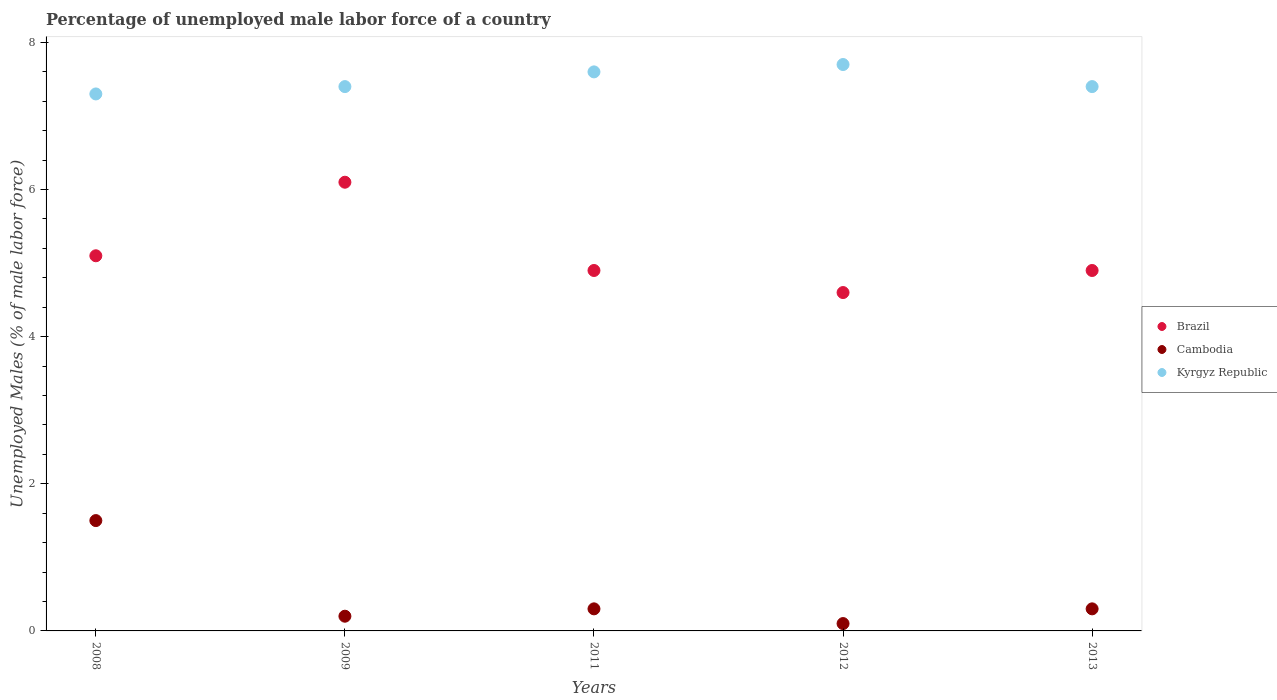How many different coloured dotlines are there?
Provide a short and direct response. 3. What is the percentage of unemployed male labor force in Kyrgyz Republic in 2009?
Keep it short and to the point. 7.4. Across all years, what is the maximum percentage of unemployed male labor force in Brazil?
Make the answer very short. 6.1. Across all years, what is the minimum percentage of unemployed male labor force in Cambodia?
Ensure brevity in your answer.  0.1. What is the total percentage of unemployed male labor force in Kyrgyz Republic in the graph?
Give a very brief answer. 37.4. What is the difference between the percentage of unemployed male labor force in Brazil in 2008 and that in 2011?
Ensure brevity in your answer.  0.2. What is the difference between the percentage of unemployed male labor force in Cambodia in 2013 and the percentage of unemployed male labor force in Kyrgyz Republic in 2009?
Give a very brief answer. -7.1. What is the average percentage of unemployed male labor force in Brazil per year?
Provide a short and direct response. 5.12. In the year 2009, what is the difference between the percentage of unemployed male labor force in Kyrgyz Republic and percentage of unemployed male labor force in Cambodia?
Provide a short and direct response. 7.2. In how many years, is the percentage of unemployed male labor force in Cambodia greater than 2.4 %?
Offer a very short reply. 0. What is the ratio of the percentage of unemployed male labor force in Cambodia in 2012 to that in 2013?
Keep it short and to the point. 0.33. What is the difference between the highest and the second highest percentage of unemployed male labor force in Brazil?
Provide a succinct answer. 1. What is the difference between the highest and the lowest percentage of unemployed male labor force in Brazil?
Keep it short and to the point. 1.5. In how many years, is the percentage of unemployed male labor force in Kyrgyz Republic greater than the average percentage of unemployed male labor force in Kyrgyz Republic taken over all years?
Your response must be concise. 2. Is it the case that in every year, the sum of the percentage of unemployed male labor force in Brazil and percentage of unemployed male labor force in Kyrgyz Republic  is greater than the percentage of unemployed male labor force in Cambodia?
Keep it short and to the point. Yes. Does the percentage of unemployed male labor force in Cambodia monotonically increase over the years?
Ensure brevity in your answer.  No. Is the percentage of unemployed male labor force in Brazil strictly greater than the percentage of unemployed male labor force in Kyrgyz Republic over the years?
Provide a succinct answer. No. Is the percentage of unemployed male labor force in Cambodia strictly less than the percentage of unemployed male labor force in Kyrgyz Republic over the years?
Provide a short and direct response. Yes. How many dotlines are there?
Provide a succinct answer. 3. What is the difference between two consecutive major ticks on the Y-axis?
Ensure brevity in your answer.  2. Does the graph contain grids?
Offer a terse response. No. What is the title of the graph?
Ensure brevity in your answer.  Percentage of unemployed male labor force of a country. What is the label or title of the Y-axis?
Provide a short and direct response. Unemployed Males (% of male labor force). What is the Unemployed Males (% of male labor force) of Brazil in 2008?
Provide a succinct answer. 5.1. What is the Unemployed Males (% of male labor force) of Kyrgyz Republic in 2008?
Give a very brief answer. 7.3. What is the Unemployed Males (% of male labor force) of Brazil in 2009?
Ensure brevity in your answer.  6.1. What is the Unemployed Males (% of male labor force) in Cambodia in 2009?
Your answer should be very brief. 0.2. What is the Unemployed Males (% of male labor force) in Kyrgyz Republic in 2009?
Give a very brief answer. 7.4. What is the Unemployed Males (% of male labor force) of Brazil in 2011?
Offer a terse response. 4.9. What is the Unemployed Males (% of male labor force) in Cambodia in 2011?
Give a very brief answer. 0.3. What is the Unemployed Males (% of male labor force) in Kyrgyz Republic in 2011?
Keep it short and to the point. 7.6. What is the Unemployed Males (% of male labor force) in Brazil in 2012?
Provide a short and direct response. 4.6. What is the Unemployed Males (% of male labor force) of Cambodia in 2012?
Give a very brief answer. 0.1. What is the Unemployed Males (% of male labor force) of Kyrgyz Republic in 2012?
Provide a short and direct response. 7.7. What is the Unemployed Males (% of male labor force) in Brazil in 2013?
Offer a terse response. 4.9. What is the Unemployed Males (% of male labor force) in Cambodia in 2013?
Give a very brief answer. 0.3. What is the Unemployed Males (% of male labor force) of Kyrgyz Republic in 2013?
Offer a very short reply. 7.4. Across all years, what is the maximum Unemployed Males (% of male labor force) in Brazil?
Offer a terse response. 6.1. Across all years, what is the maximum Unemployed Males (% of male labor force) of Kyrgyz Republic?
Ensure brevity in your answer.  7.7. Across all years, what is the minimum Unemployed Males (% of male labor force) of Brazil?
Your response must be concise. 4.6. Across all years, what is the minimum Unemployed Males (% of male labor force) of Cambodia?
Ensure brevity in your answer.  0.1. Across all years, what is the minimum Unemployed Males (% of male labor force) in Kyrgyz Republic?
Make the answer very short. 7.3. What is the total Unemployed Males (% of male labor force) of Brazil in the graph?
Your answer should be compact. 25.6. What is the total Unemployed Males (% of male labor force) of Kyrgyz Republic in the graph?
Provide a succinct answer. 37.4. What is the difference between the Unemployed Males (% of male labor force) of Brazil in 2008 and that in 2009?
Offer a terse response. -1. What is the difference between the Unemployed Males (% of male labor force) of Cambodia in 2008 and that in 2009?
Provide a short and direct response. 1.3. What is the difference between the Unemployed Males (% of male labor force) in Kyrgyz Republic in 2008 and that in 2012?
Ensure brevity in your answer.  -0.4. What is the difference between the Unemployed Males (% of male labor force) of Brazil in 2008 and that in 2013?
Keep it short and to the point. 0.2. What is the difference between the Unemployed Males (% of male labor force) in Cambodia in 2008 and that in 2013?
Your response must be concise. 1.2. What is the difference between the Unemployed Males (% of male labor force) of Brazil in 2009 and that in 2011?
Your answer should be very brief. 1.2. What is the difference between the Unemployed Males (% of male labor force) in Cambodia in 2009 and that in 2011?
Offer a very short reply. -0.1. What is the difference between the Unemployed Males (% of male labor force) of Kyrgyz Republic in 2009 and that in 2011?
Give a very brief answer. -0.2. What is the difference between the Unemployed Males (% of male labor force) of Brazil in 2009 and that in 2012?
Make the answer very short. 1.5. What is the difference between the Unemployed Males (% of male labor force) of Cambodia in 2009 and that in 2012?
Your answer should be compact. 0.1. What is the difference between the Unemployed Males (% of male labor force) of Kyrgyz Republic in 2009 and that in 2013?
Your response must be concise. 0. What is the difference between the Unemployed Males (% of male labor force) in Cambodia in 2011 and that in 2012?
Make the answer very short. 0.2. What is the difference between the Unemployed Males (% of male labor force) in Brazil in 2011 and that in 2013?
Make the answer very short. 0. What is the difference between the Unemployed Males (% of male labor force) in Cambodia in 2011 and that in 2013?
Your answer should be very brief. 0. What is the difference between the Unemployed Males (% of male labor force) of Cambodia in 2008 and the Unemployed Males (% of male labor force) of Kyrgyz Republic in 2009?
Your answer should be very brief. -5.9. What is the difference between the Unemployed Males (% of male labor force) in Brazil in 2008 and the Unemployed Males (% of male labor force) in Cambodia in 2011?
Keep it short and to the point. 4.8. What is the difference between the Unemployed Males (% of male labor force) of Brazil in 2008 and the Unemployed Males (% of male labor force) of Kyrgyz Republic in 2011?
Your answer should be very brief. -2.5. What is the difference between the Unemployed Males (% of male labor force) of Brazil in 2008 and the Unemployed Males (% of male labor force) of Cambodia in 2013?
Your answer should be very brief. 4.8. What is the difference between the Unemployed Males (% of male labor force) of Brazil in 2008 and the Unemployed Males (% of male labor force) of Kyrgyz Republic in 2013?
Your answer should be compact. -2.3. What is the difference between the Unemployed Males (% of male labor force) in Cambodia in 2008 and the Unemployed Males (% of male labor force) in Kyrgyz Republic in 2013?
Give a very brief answer. -5.9. What is the difference between the Unemployed Males (% of male labor force) in Cambodia in 2009 and the Unemployed Males (% of male labor force) in Kyrgyz Republic in 2012?
Give a very brief answer. -7.5. What is the difference between the Unemployed Males (% of male labor force) in Brazil in 2009 and the Unemployed Males (% of male labor force) in Kyrgyz Republic in 2013?
Ensure brevity in your answer.  -1.3. What is the difference between the Unemployed Males (% of male labor force) of Cambodia in 2009 and the Unemployed Males (% of male labor force) of Kyrgyz Republic in 2013?
Offer a very short reply. -7.2. What is the difference between the Unemployed Males (% of male labor force) in Brazil in 2011 and the Unemployed Males (% of male labor force) in Cambodia in 2012?
Your response must be concise. 4.8. What is the difference between the Unemployed Males (% of male labor force) of Brazil in 2011 and the Unemployed Males (% of male labor force) of Cambodia in 2013?
Provide a succinct answer. 4.6. What is the difference between the Unemployed Males (% of male labor force) in Cambodia in 2011 and the Unemployed Males (% of male labor force) in Kyrgyz Republic in 2013?
Your response must be concise. -7.1. What is the difference between the Unemployed Males (% of male labor force) in Brazil in 2012 and the Unemployed Males (% of male labor force) in Kyrgyz Republic in 2013?
Make the answer very short. -2.8. What is the average Unemployed Males (% of male labor force) of Brazil per year?
Provide a short and direct response. 5.12. What is the average Unemployed Males (% of male labor force) of Cambodia per year?
Give a very brief answer. 0.48. What is the average Unemployed Males (% of male labor force) in Kyrgyz Republic per year?
Give a very brief answer. 7.48. In the year 2008, what is the difference between the Unemployed Males (% of male labor force) in Brazil and Unemployed Males (% of male labor force) in Kyrgyz Republic?
Make the answer very short. -2.2. In the year 2009, what is the difference between the Unemployed Males (% of male labor force) in Brazil and Unemployed Males (% of male labor force) in Cambodia?
Make the answer very short. 5.9. In the year 2009, what is the difference between the Unemployed Males (% of male labor force) of Brazil and Unemployed Males (% of male labor force) of Kyrgyz Republic?
Your answer should be very brief. -1.3. In the year 2009, what is the difference between the Unemployed Males (% of male labor force) of Cambodia and Unemployed Males (% of male labor force) of Kyrgyz Republic?
Provide a short and direct response. -7.2. In the year 2011, what is the difference between the Unemployed Males (% of male labor force) of Cambodia and Unemployed Males (% of male labor force) of Kyrgyz Republic?
Make the answer very short. -7.3. In the year 2012, what is the difference between the Unemployed Males (% of male labor force) in Brazil and Unemployed Males (% of male labor force) in Cambodia?
Ensure brevity in your answer.  4.5. In the year 2012, what is the difference between the Unemployed Males (% of male labor force) of Brazil and Unemployed Males (% of male labor force) of Kyrgyz Republic?
Give a very brief answer. -3.1. In the year 2012, what is the difference between the Unemployed Males (% of male labor force) of Cambodia and Unemployed Males (% of male labor force) of Kyrgyz Republic?
Your response must be concise. -7.6. In the year 2013, what is the difference between the Unemployed Males (% of male labor force) of Brazil and Unemployed Males (% of male labor force) of Cambodia?
Provide a succinct answer. 4.6. In the year 2013, what is the difference between the Unemployed Males (% of male labor force) of Brazil and Unemployed Males (% of male labor force) of Kyrgyz Republic?
Offer a terse response. -2.5. What is the ratio of the Unemployed Males (% of male labor force) of Brazil in 2008 to that in 2009?
Ensure brevity in your answer.  0.84. What is the ratio of the Unemployed Males (% of male labor force) of Cambodia in 2008 to that in 2009?
Offer a very short reply. 7.5. What is the ratio of the Unemployed Males (% of male labor force) of Kyrgyz Republic in 2008 to that in 2009?
Ensure brevity in your answer.  0.99. What is the ratio of the Unemployed Males (% of male labor force) of Brazil in 2008 to that in 2011?
Your answer should be compact. 1.04. What is the ratio of the Unemployed Males (% of male labor force) of Kyrgyz Republic in 2008 to that in 2011?
Provide a short and direct response. 0.96. What is the ratio of the Unemployed Males (% of male labor force) of Brazil in 2008 to that in 2012?
Offer a very short reply. 1.11. What is the ratio of the Unemployed Males (% of male labor force) of Cambodia in 2008 to that in 2012?
Your answer should be very brief. 15. What is the ratio of the Unemployed Males (% of male labor force) in Kyrgyz Republic in 2008 to that in 2012?
Make the answer very short. 0.95. What is the ratio of the Unemployed Males (% of male labor force) in Brazil in 2008 to that in 2013?
Offer a very short reply. 1.04. What is the ratio of the Unemployed Males (% of male labor force) of Cambodia in 2008 to that in 2013?
Provide a short and direct response. 5. What is the ratio of the Unemployed Males (% of male labor force) in Kyrgyz Republic in 2008 to that in 2013?
Your answer should be very brief. 0.99. What is the ratio of the Unemployed Males (% of male labor force) in Brazil in 2009 to that in 2011?
Provide a short and direct response. 1.24. What is the ratio of the Unemployed Males (% of male labor force) of Cambodia in 2009 to that in 2011?
Make the answer very short. 0.67. What is the ratio of the Unemployed Males (% of male labor force) of Kyrgyz Republic in 2009 to that in 2011?
Give a very brief answer. 0.97. What is the ratio of the Unemployed Males (% of male labor force) in Brazil in 2009 to that in 2012?
Your answer should be very brief. 1.33. What is the ratio of the Unemployed Males (% of male labor force) in Brazil in 2009 to that in 2013?
Give a very brief answer. 1.24. What is the ratio of the Unemployed Males (% of male labor force) of Cambodia in 2009 to that in 2013?
Offer a terse response. 0.67. What is the ratio of the Unemployed Males (% of male labor force) of Kyrgyz Republic in 2009 to that in 2013?
Make the answer very short. 1. What is the ratio of the Unemployed Males (% of male labor force) in Brazil in 2011 to that in 2012?
Keep it short and to the point. 1.07. What is the ratio of the Unemployed Males (% of male labor force) of Kyrgyz Republic in 2011 to that in 2012?
Your answer should be compact. 0.99. What is the ratio of the Unemployed Males (% of male labor force) of Brazil in 2011 to that in 2013?
Offer a terse response. 1. What is the ratio of the Unemployed Males (% of male labor force) of Brazil in 2012 to that in 2013?
Keep it short and to the point. 0.94. What is the ratio of the Unemployed Males (% of male labor force) of Kyrgyz Republic in 2012 to that in 2013?
Your answer should be compact. 1.04. What is the difference between the highest and the lowest Unemployed Males (% of male labor force) of Brazil?
Provide a succinct answer. 1.5. What is the difference between the highest and the lowest Unemployed Males (% of male labor force) of Cambodia?
Ensure brevity in your answer.  1.4. What is the difference between the highest and the lowest Unemployed Males (% of male labor force) of Kyrgyz Republic?
Provide a succinct answer. 0.4. 